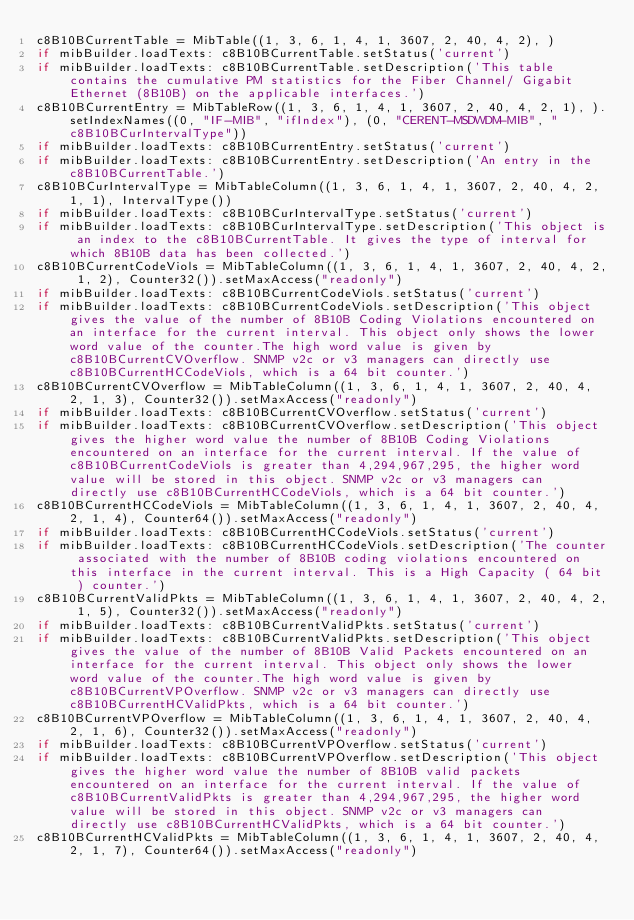Convert code to text. <code><loc_0><loc_0><loc_500><loc_500><_Python_>c8B10BCurrentTable = MibTable((1, 3, 6, 1, 4, 1, 3607, 2, 40, 4, 2), )
if mibBuilder.loadTexts: c8B10BCurrentTable.setStatus('current')
if mibBuilder.loadTexts: c8B10BCurrentTable.setDescription('This table contains the cumulative PM statistics for the Fiber Channel/ Gigabit Ethernet (8B10B) on the applicable interfaces.')
c8B10BCurrentEntry = MibTableRow((1, 3, 6, 1, 4, 1, 3607, 2, 40, 4, 2, 1), ).setIndexNames((0, "IF-MIB", "ifIndex"), (0, "CERENT-MSDWDM-MIB", "c8B10BCurIntervalType"))
if mibBuilder.loadTexts: c8B10BCurrentEntry.setStatus('current')
if mibBuilder.loadTexts: c8B10BCurrentEntry.setDescription('An entry in the c8B10BCurrentTable.')
c8B10BCurIntervalType = MibTableColumn((1, 3, 6, 1, 4, 1, 3607, 2, 40, 4, 2, 1, 1), IntervalType())
if mibBuilder.loadTexts: c8B10BCurIntervalType.setStatus('current')
if mibBuilder.loadTexts: c8B10BCurIntervalType.setDescription('This object is an index to the c8B10BCurrentTable. It gives the type of interval for which 8B10B data has been collected.')
c8B10BCurrentCodeViols = MibTableColumn((1, 3, 6, 1, 4, 1, 3607, 2, 40, 4, 2, 1, 2), Counter32()).setMaxAccess("readonly")
if mibBuilder.loadTexts: c8B10BCurrentCodeViols.setStatus('current')
if mibBuilder.loadTexts: c8B10BCurrentCodeViols.setDescription('This object gives the value of the number of 8B10B Coding Violations encountered on an interface for the current interval. This object only shows the lower word value of the counter.The high word value is given by c8B10BCurrentCVOverflow. SNMP v2c or v3 managers can directly use c8B10BCurrentHCCodeViols, which is a 64 bit counter.')
c8B10BCurrentCVOverflow = MibTableColumn((1, 3, 6, 1, 4, 1, 3607, 2, 40, 4, 2, 1, 3), Counter32()).setMaxAccess("readonly")
if mibBuilder.loadTexts: c8B10BCurrentCVOverflow.setStatus('current')
if mibBuilder.loadTexts: c8B10BCurrentCVOverflow.setDescription('This object gives the higher word value the number of 8B10B Coding Violations encountered on an interface for the current interval. If the value of c8B10BCurrentCodeViols is greater than 4,294,967,295, the higher word value will be stored in this object. SNMP v2c or v3 managers can directly use c8B10BCurrentHCCodeViols, which is a 64 bit counter.')
c8B10BCurrentHCCodeViols = MibTableColumn((1, 3, 6, 1, 4, 1, 3607, 2, 40, 4, 2, 1, 4), Counter64()).setMaxAccess("readonly")
if mibBuilder.loadTexts: c8B10BCurrentHCCodeViols.setStatus('current')
if mibBuilder.loadTexts: c8B10BCurrentHCCodeViols.setDescription('The counter associated with the number of 8B10B coding violations encountered on this interface in the current interval. This is a High Capacity ( 64 bit ) counter.')
c8B10BCurrentValidPkts = MibTableColumn((1, 3, 6, 1, 4, 1, 3607, 2, 40, 4, 2, 1, 5), Counter32()).setMaxAccess("readonly")
if mibBuilder.loadTexts: c8B10BCurrentValidPkts.setStatus('current')
if mibBuilder.loadTexts: c8B10BCurrentValidPkts.setDescription('This object gives the value of the number of 8B10B Valid Packets encountered on an interface for the current interval. This object only shows the lower word value of the counter.The high word value is given by c8B10BCurrentVPOverflow. SNMP v2c or v3 managers can directly use c8B10BCurrentHCValidPkts, which is a 64 bit counter.')
c8B10BCurrentVPOverflow = MibTableColumn((1, 3, 6, 1, 4, 1, 3607, 2, 40, 4, 2, 1, 6), Counter32()).setMaxAccess("readonly")
if mibBuilder.loadTexts: c8B10BCurrentVPOverflow.setStatus('current')
if mibBuilder.loadTexts: c8B10BCurrentVPOverflow.setDescription('This object gives the higher word value the number of 8B10B valid packets encountered on an interface for the current interval. If the value of c8B10BCurrentValidPkts is greater than 4,294,967,295, the higher word value will be stored in this object. SNMP v2c or v3 managers can directly use c8B10BCurrentHCValidPkts, which is a 64 bit counter.')
c8B10BCurrentHCValidPkts = MibTableColumn((1, 3, 6, 1, 4, 1, 3607, 2, 40, 4, 2, 1, 7), Counter64()).setMaxAccess("readonly")</code> 